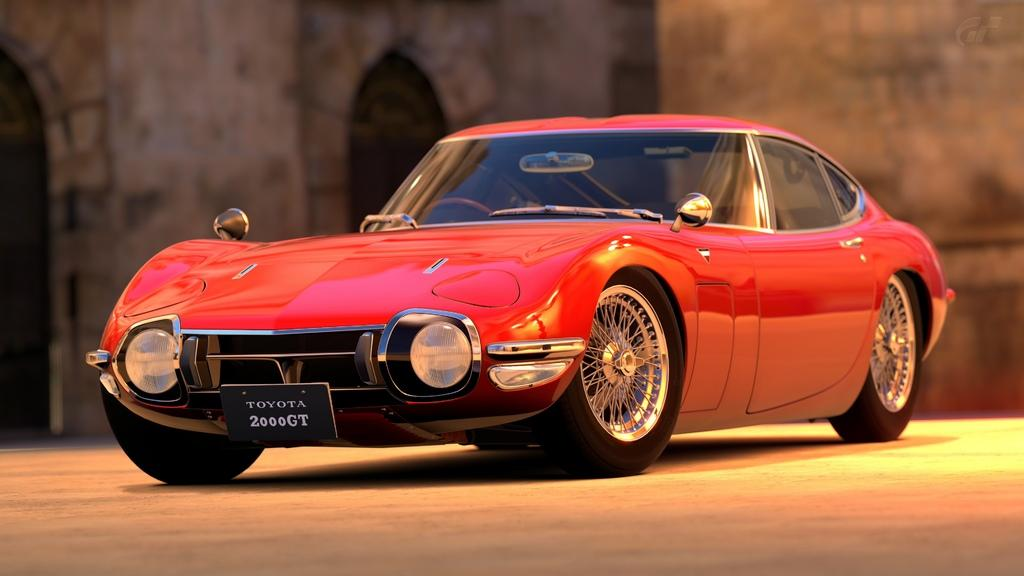What color is the car in the image? The car in the image is red. Where is the car located in the image? The car is on the ground. Can you describe the background of the image? The background of the image is blurred. Is the car connected to a cable in the image? There is no cable present in the image, and the car is not connected to one. 